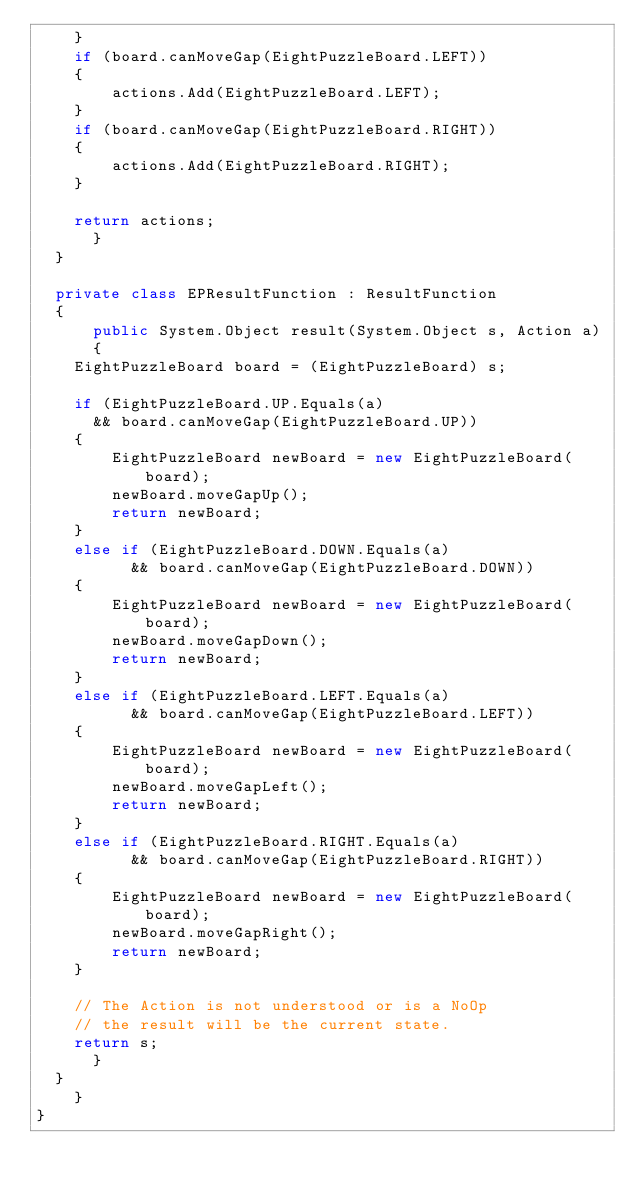<code> <loc_0><loc_0><loc_500><loc_500><_C#_>		}
		if (board.canMoveGap(EightPuzzleBoard.LEFT))
		{
		    actions.Add(EightPuzzleBoard.LEFT);
		}
		if (board.canMoveGap(EightPuzzleBoard.RIGHT))
		{
		    actions.Add(EightPuzzleBoard.RIGHT);
		}

		return actions;
	    }
	}

	private class EPResultFunction : ResultFunction
	{
	    public System.Object result(System.Object s, Action a)
	    {
		EightPuzzleBoard board = (EightPuzzleBoard) s;

		if (EightPuzzleBoard.UP.Equals(a)
			&& board.canMoveGap(EightPuzzleBoard.UP))
		{
		    EightPuzzleBoard newBoard = new EightPuzzleBoard(board);
		    newBoard.moveGapUp();
		    return newBoard;
		}
		else if (EightPuzzleBoard.DOWN.Equals(a)
		      && board.canMoveGap(EightPuzzleBoard.DOWN))
		{
		    EightPuzzleBoard newBoard = new EightPuzzleBoard(board);
		    newBoard.moveGapDown();
		    return newBoard;
		}
		else if (EightPuzzleBoard.LEFT.Equals(a)
		      && board.canMoveGap(EightPuzzleBoard.LEFT))
		{
		    EightPuzzleBoard newBoard = new EightPuzzleBoard(board);
		    newBoard.moveGapLeft();
		    return newBoard;
		}
		else if (EightPuzzleBoard.RIGHT.Equals(a)
		      && board.canMoveGap(EightPuzzleBoard.RIGHT))
		{
		    EightPuzzleBoard newBoard = new EightPuzzleBoard(board);
		    newBoard.moveGapRight();
		    return newBoard;
		}

		// The Action is not understood or is a NoOp
		// the result will be the current state.
		return s;
	    }
	}
    }
}</code> 